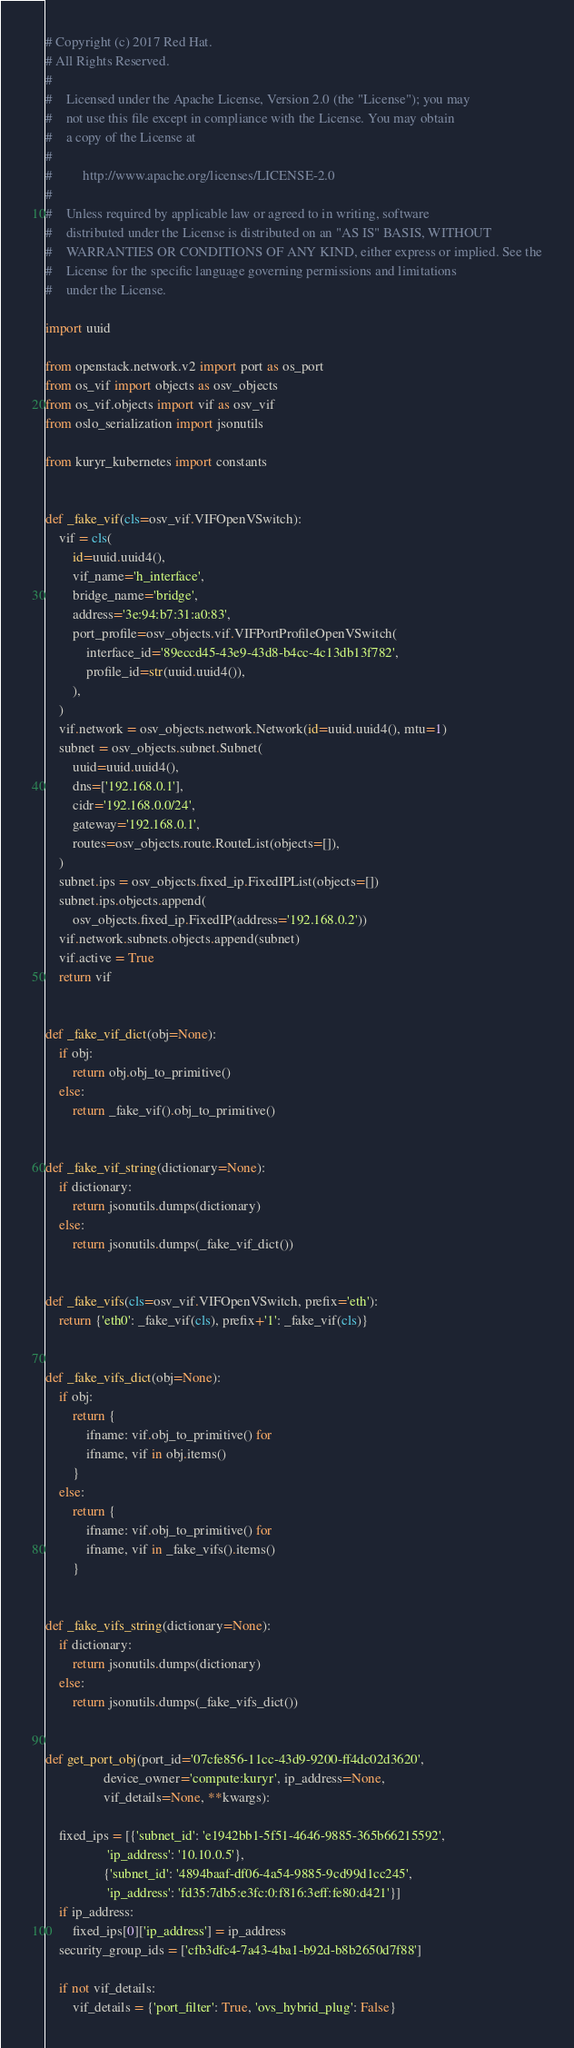<code> <loc_0><loc_0><loc_500><loc_500><_Python_># Copyright (c) 2017 Red Hat.
# All Rights Reserved.
#
#    Licensed under the Apache License, Version 2.0 (the "License"); you may
#    not use this file except in compliance with the License. You may obtain
#    a copy of the License at
#
#         http://www.apache.org/licenses/LICENSE-2.0
#
#    Unless required by applicable law or agreed to in writing, software
#    distributed under the License is distributed on an "AS IS" BASIS, WITHOUT
#    WARRANTIES OR CONDITIONS OF ANY KIND, either express or implied. See the
#    License for the specific language governing permissions and limitations
#    under the License.

import uuid

from openstack.network.v2 import port as os_port
from os_vif import objects as osv_objects
from os_vif.objects import vif as osv_vif
from oslo_serialization import jsonutils

from kuryr_kubernetes import constants


def _fake_vif(cls=osv_vif.VIFOpenVSwitch):
    vif = cls(
        id=uuid.uuid4(),
        vif_name='h_interface',
        bridge_name='bridge',
        address='3e:94:b7:31:a0:83',
        port_profile=osv_objects.vif.VIFPortProfileOpenVSwitch(
            interface_id='89eccd45-43e9-43d8-b4cc-4c13db13f782',
            profile_id=str(uuid.uuid4()),
        ),
    )
    vif.network = osv_objects.network.Network(id=uuid.uuid4(), mtu=1)
    subnet = osv_objects.subnet.Subnet(
        uuid=uuid.uuid4(),
        dns=['192.168.0.1'],
        cidr='192.168.0.0/24',
        gateway='192.168.0.1',
        routes=osv_objects.route.RouteList(objects=[]),
    )
    subnet.ips = osv_objects.fixed_ip.FixedIPList(objects=[])
    subnet.ips.objects.append(
        osv_objects.fixed_ip.FixedIP(address='192.168.0.2'))
    vif.network.subnets.objects.append(subnet)
    vif.active = True
    return vif


def _fake_vif_dict(obj=None):
    if obj:
        return obj.obj_to_primitive()
    else:
        return _fake_vif().obj_to_primitive()


def _fake_vif_string(dictionary=None):
    if dictionary:
        return jsonutils.dumps(dictionary)
    else:
        return jsonutils.dumps(_fake_vif_dict())


def _fake_vifs(cls=osv_vif.VIFOpenVSwitch, prefix='eth'):
    return {'eth0': _fake_vif(cls), prefix+'1': _fake_vif(cls)}


def _fake_vifs_dict(obj=None):
    if obj:
        return {
            ifname: vif.obj_to_primitive() for
            ifname, vif in obj.items()
        }
    else:
        return {
            ifname: vif.obj_to_primitive() for
            ifname, vif in _fake_vifs().items()
        }


def _fake_vifs_string(dictionary=None):
    if dictionary:
        return jsonutils.dumps(dictionary)
    else:
        return jsonutils.dumps(_fake_vifs_dict())


def get_port_obj(port_id='07cfe856-11cc-43d9-9200-ff4dc02d3620',
                 device_owner='compute:kuryr', ip_address=None,
                 vif_details=None, **kwargs):

    fixed_ips = [{'subnet_id': 'e1942bb1-5f51-4646-9885-365b66215592',
                  'ip_address': '10.10.0.5'},
                 {'subnet_id': '4894baaf-df06-4a54-9885-9cd99d1cc245',
                  'ip_address': 'fd35:7db5:e3fc:0:f816:3eff:fe80:d421'}]
    if ip_address:
        fixed_ips[0]['ip_address'] = ip_address
    security_group_ids = ['cfb3dfc4-7a43-4ba1-b92d-b8b2650d7f88']

    if not vif_details:
        vif_details = {'port_filter': True, 'ovs_hybrid_plug': False}
</code> 